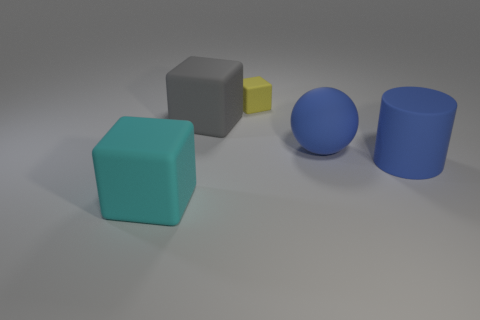What shape is the thing that is the same color as the rubber ball?
Ensure brevity in your answer.  Cylinder. What number of other objects are the same size as the yellow rubber thing?
Make the answer very short. 0. Are there an equal number of gray matte things that are to the right of the large cyan matte block and yellow matte cubes that are to the right of the big gray rubber block?
Offer a very short reply. Yes. There is a small object that is the same shape as the big cyan rubber object; what is its color?
Make the answer very short. Yellow. Do the big object right of the blue rubber sphere and the ball have the same color?
Provide a short and direct response. Yes. What is the size of the gray object that is the same shape as the big cyan thing?
Ensure brevity in your answer.  Large. How many cylinders have the same material as the big sphere?
Provide a short and direct response. 1. Is there a blue rubber cylinder on the right side of the large blue object that is on the left side of the object on the right side of the big matte sphere?
Provide a short and direct response. Yes. What is the shape of the gray matte object?
Provide a succinct answer. Cube. How many other cubes are the same color as the tiny rubber cube?
Offer a very short reply. 0. 